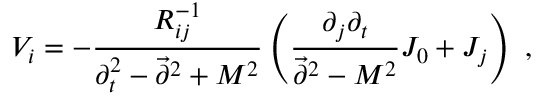<formula> <loc_0><loc_0><loc_500><loc_500>V _ { i } = - { \frac { R _ { i j } ^ { - 1 } } { \partial _ { t } ^ { 2 } - \vec { \partial } ^ { 2 } + M ^ { 2 } } } \left ( { \frac { \partial _ { j } \partial _ { t } } { \vec { \partial } ^ { 2 } - M ^ { 2 } } } J _ { 0 } + J _ { j } \right ) ,</formula> 